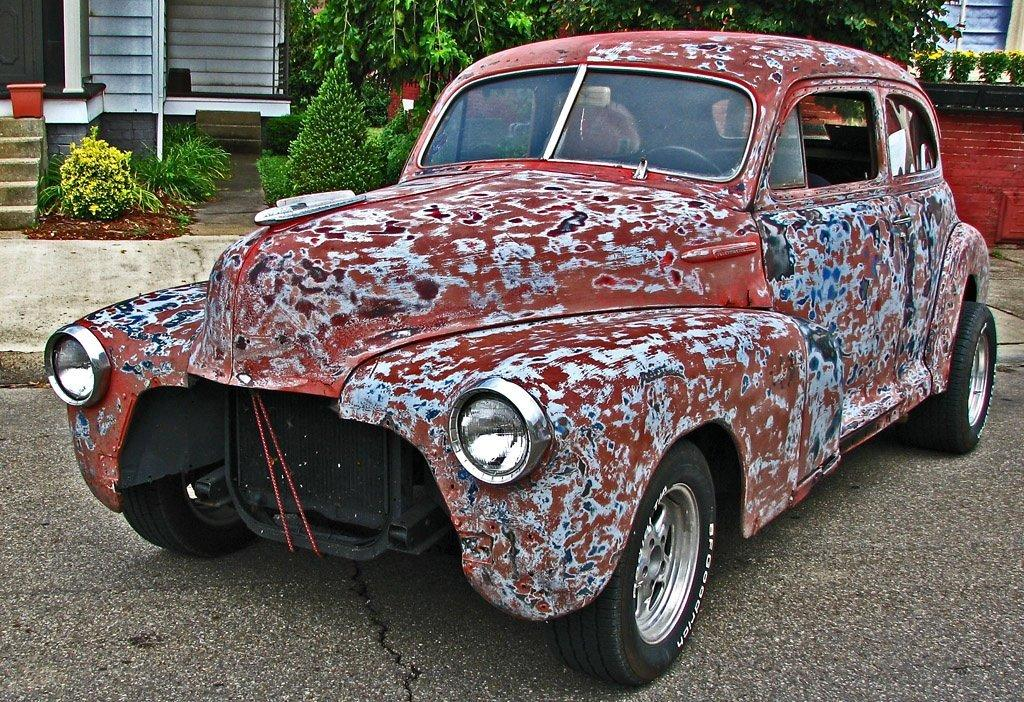What is the main subject of the image? The main subject of the image is a car. Can you describe the car's features? The car has multiple headlights and glasses. Where is the car located in the image? The car is parked on the road. What can be seen in the background of the image? There are plants, trees, buildings, and a staircase in the background of the image. What type of paste is being used to fix the credit card in the image? There is no paste or credit card present in the image; it features a car parked on the road with a background of plants, trees, buildings, and a staircase. 